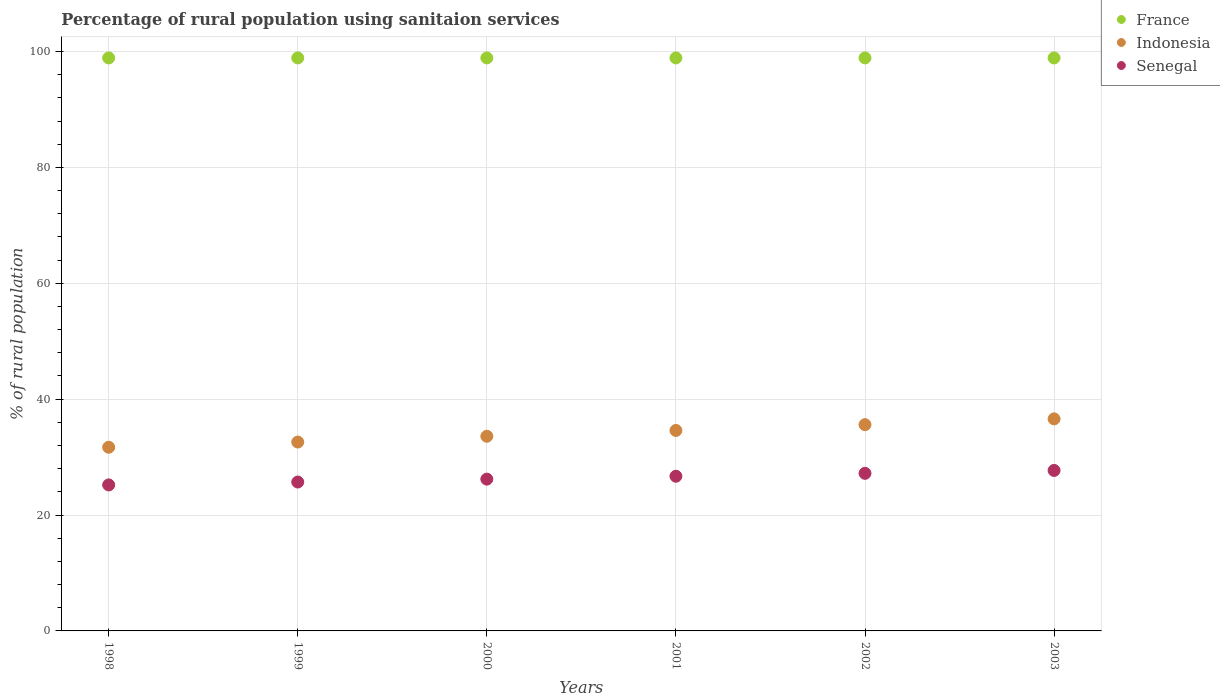How many different coloured dotlines are there?
Offer a very short reply. 3. What is the percentage of rural population using sanitaion services in Indonesia in 2001?
Your answer should be very brief. 34.6. Across all years, what is the maximum percentage of rural population using sanitaion services in Senegal?
Keep it short and to the point. 27.7. Across all years, what is the minimum percentage of rural population using sanitaion services in Senegal?
Keep it short and to the point. 25.2. In which year was the percentage of rural population using sanitaion services in Senegal maximum?
Make the answer very short. 2003. What is the total percentage of rural population using sanitaion services in France in the graph?
Offer a very short reply. 593.4. What is the difference between the percentage of rural population using sanitaion services in Senegal in 1998 and that in 2000?
Give a very brief answer. -1. What is the difference between the percentage of rural population using sanitaion services in Senegal in 2003 and the percentage of rural population using sanitaion services in Indonesia in 2001?
Your answer should be very brief. -6.9. What is the average percentage of rural population using sanitaion services in France per year?
Offer a very short reply. 98.9. In the year 1999, what is the difference between the percentage of rural population using sanitaion services in Senegal and percentage of rural population using sanitaion services in France?
Provide a succinct answer. -73.2. What is the ratio of the percentage of rural population using sanitaion services in Senegal in 2000 to that in 2001?
Your response must be concise. 0.98. What is the difference between the highest and the second highest percentage of rural population using sanitaion services in France?
Provide a short and direct response. 0. What is the difference between the highest and the lowest percentage of rural population using sanitaion services in Senegal?
Provide a succinct answer. 2.5. In how many years, is the percentage of rural population using sanitaion services in France greater than the average percentage of rural population using sanitaion services in France taken over all years?
Ensure brevity in your answer.  6. Is the sum of the percentage of rural population using sanitaion services in Senegal in 1998 and 2000 greater than the maximum percentage of rural population using sanitaion services in France across all years?
Your answer should be very brief. No. How many dotlines are there?
Provide a succinct answer. 3. How many years are there in the graph?
Offer a terse response. 6. What is the difference between two consecutive major ticks on the Y-axis?
Make the answer very short. 20. Does the graph contain any zero values?
Your answer should be compact. No. Where does the legend appear in the graph?
Your response must be concise. Top right. How many legend labels are there?
Offer a very short reply. 3. What is the title of the graph?
Your answer should be very brief. Percentage of rural population using sanitaion services. Does "OECD members" appear as one of the legend labels in the graph?
Provide a short and direct response. No. What is the label or title of the X-axis?
Your answer should be compact. Years. What is the label or title of the Y-axis?
Offer a very short reply. % of rural population. What is the % of rural population in France in 1998?
Make the answer very short. 98.9. What is the % of rural population in Indonesia in 1998?
Provide a succinct answer. 31.7. What is the % of rural population in Senegal in 1998?
Your answer should be compact. 25.2. What is the % of rural population in France in 1999?
Provide a short and direct response. 98.9. What is the % of rural population in Indonesia in 1999?
Keep it short and to the point. 32.6. What is the % of rural population in Senegal in 1999?
Your response must be concise. 25.7. What is the % of rural population of France in 2000?
Ensure brevity in your answer.  98.9. What is the % of rural population in Indonesia in 2000?
Give a very brief answer. 33.6. What is the % of rural population in Senegal in 2000?
Your answer should be very brief. 26.2. What is the % of rural population in France in 2001?
Your answer should be compact. 98.9. What is the % of rural population in Indonesia in 2001?
Provide a short and direct response. 34.6. What is the % of rural population of Senegal in 2001?
Provide a short and direct response. 26.7. What is the % of rural population of France in 2002?
Provide a short and direct response. 98.9. What is the % of rural population in Indonesia in 2002?
Your answer should be compact. 35.6. What is the % of rural population of Senegal in 2002?
Ensure brevity in your answer.  27.2. What is the % of rural population of France in 2003?
Offer a terse response. 98.9. What is the % of rural population in Indonesia in 2003?
Offer a very short reply. 36.6. What is the % of rural population in Senegal in 2003?
Make the answer very short. 27.7. Across all years, what is the maximum % of rural population of France?
Provide a short and direct response. 98.9. Across all years, what is the maximum % of rural population of Indonesia?
Provide a short and direct response. 36.6. Across all years, what is the maximum % of rural population of Senegal?
Your response must be concise. 27.7. Across all years, what is the minimum % of rural population of France?
Provide a succinct answer. 98.9. Across all years, what is the minimum % of rural population in Indonesia?
Keep it short and to the point. 31.7. Across all years, what is the minimum % of rural population of Senegal?
Make the answer very short. 25.2. What is the total % of rural population in France in the graph?
Make the answer very short. 593.4. What is the total % of rural population of Indonesia in the graph?
Ensure brevity in your answer.  204.7. What is the total % of rural population in Senegal in the graph?
Offer a terse response. 158.7. What is the difference between the % of rural population in Indonesia in 1998 and that in 1999?
Your answer should be compact. -0.9. What is the difference between the % of rural population in Indonesia in 1998 and that in 2000?
Keep it short and to the point. -1.9. What is the difference between the % of rural population in France in 1998 and that in 2001?
Provide a short and direct response. 0. What is the difference between the % of rural population in Senegal in 1998 and that in 2002?
Make the answer very short. -2. What is the difference between the % of rural population in Senegal in 1998 and that in 2003?
Make the answer very short. -2.5. What is the difference between the % of rural population of France in 1999 and that in 2000?
Make the answer very short. 0. What is the difference between the % of rural population in Indonesia in 1999 and that in 2000?
Your response must be concise. -1. What is the difference between the % of rural population in Senegal in 1999 and that in 2000?
Give a very brief answer. -0.5. What is the difference between the % of rural population of Indonesia in 1999 and that in 2001?
Provide a short and direct response. -2. What is the difference between the % of rural population in Senegal in 1999 and that in 2001?
Provide a short and direct response. -1. What is the difference between the % of rural population of France in 1999 and that in 2002?
Your answer should be compact. 0. What is the difference between the % of rural population in France in 2000 and that in 2001?
Provide a succinct answer. 0. What is the difference between the % of rural population in Indonesia in 2000 and that in 2001?
Your answer should be compact. -1. What is the difference between the % of rural population in Senegal in 2000 and that in 2001?
Make the answer very short. -0.5. What is the difference between the % of rural population of Indonesia in 2000 and that in 2002?
Make the answer very short. -2. What is the difference between the % of rural population of Senegal in 2000 and that in 2002?
Your answer should be compact. -1. What is the difference between the % of rural population in France in 2001 and that in 2002?
Your answer should be compact. 0. What is the difference between the % of rural population of Indonesia in 2001 and that in 2002?
Give a very brief answer. -1. What is the difference between the % of rural population of France in 2001 and that in 2003?
Give a very brief answer. 0. What is the difference between the % of rural population of Indonesia in 2001 and that in 2003?
Provide a short and direct response. -2. What is the difference between the % of rural population in Senegal in 2001 and that in 2003?
Provide a short and direct response. -1. What is the difference between the % of rural population of Senegal in 2002 and that in 2003?
Ensure brevity in your answer.  -0.5. What is the difference between the % of rural population in France in 1998 and the % of rural population in Indonesia in 1999?
Provide a short and direct response. 66.3. What is the difference between the % of rural population in France in 1998 and the % of rural population in Senegal in 1999?
Offer a terse response. 73.2. What is the difference between the % of rural population in Indonesia in 1998 and the % of rural population in Senegal in 1999?
Offer a terse response. 6. What is the difference between the % of rural population in France in 1998 and the % of rural population in Indonesia in 2000?
Give a very brief answer. 65.3. What is the difference between the % of rural population of France in 1998 and the % of rural population of Senegal in 2000?
Your response must be concise. 72.7. What is the difference between the % of rural population of France in 1998 and the % of rural population of Indonesia in 2001?
Your answer should be compact. 64.3. What is the difference between the % of rural population in France in 1998 and the % of rural population in Senegal in 2001?
Ensure brevity in your answer.  72.2. What is the difference between the % of rural population of Indonesia in 1998 and the % of rural population of Senegal in 2001?
Your answer should be very brief. 5. What is the difference between the % of rural population of France in 1998 and the % of rural population of Indonesia in 2002?
Provide a succinct answer. 63.3. What is the difference between the % of rural population of France in 1998 and the % of rural population of Senegal in 2002?
Give a very brief answer. 71.7. What is the difference between the % of rural population of France in 1998 and the % of rural population of Indonesia in 2003?
Your response must be concise. 62.3. What is the difference between the % of rural population of France in 1998 and the % of rural population of Senegal in 2003?
Your answer should be very brief. 71.2. What is the difference between the % of rural population of France in 1999 and the % of rural population of Indonesia in 2000?
Your answer should be compact. 65.3. What is the difference between the % of rural population in France in 1999 and the % of rural population in Senegal in 2000?
Provide a succinct answer. 72.7. What is the difference between the % of rural population of Indonesia in 1999 and the % of rural population of Senegal in 2000?
Provide a succinct answer. 6.4. What is the difference between the % of rural population of France in 1999 and the % of rural population of Indonesia in 2001?
Give a very brief answer. 64.3. What is the difference between the % of rural population in France in 1999 and the % of rural population in Senegal in 2001?
Provide a short and direct response. 72.2. What is the difference between the % of rural population in France in 1999 and the % of rural population in Indonesia in 2002?
Make the answer very short. 63.3. What is the difference between the % of rural population in France in 1999 and the % of rural population in Senegal in 2002?
Your answer should be compact. 71.7. What is the difference between the % of rural population of France in 1999 and the % of rural population of Indonesia in 2003?
Provide a succinct answer. 62.3. What is the difference between the % of rural population in France in 1999 and the % of rural population in Senegal in 2003?
Make the answer very short. 71.2. What is the difference between the % of rural population in Indonesia in 1999 and the % of rural population in Senegal in 2003?
Provide a short and direct response. 4.9. What is the difference between the % of rural population of France in 2000 and the % of rural population of Indonesia in 2001?
Provide a succinct answer. 64.3. What is the difference between the % of rural population in France in 2000 and the % of rural population in Senegal in 2001?
Keep it short and to the point. 72.2. What is the difference between the % of rural population in Indonesia in 2000 and the % of rural population in Senegal in 2001?
Provide a succinct answer. 6.9. What is the difference between the % of rural population of France in 2000 and the % of rural population of Indonesia in 2002?
Offer a very short reply. 63.3. What is the difference between the % of rural population of France in 2000 and the % of rural population of Senegal in 2002?
Your response must be concise. 71.7. What is the difference between the % of rural population of Indonesia in 2000 and the % of rural population of Senegal in 2002?
Your response must be concise. 6.4. What is the difference between the % of rural population of France in 2000 and the % of rural population of Indonesia in 2003?
Provide a short and direct response. 62.3. What is the difference between the % of rural population in France in 2000 and the % of rural population in Senegal in 2003?
Keep it short and to the point. 71.2. What is the difference between the % of rural population in Indonesia in 2000 and the % of rural population in Senegal in 2003?
Keep it short and to the point. 5.9. What is the difference between the % of rural population in France in 2001 and the % of rural population in Indonesia in 2002?
Make the answer very short. 63.3. What is the difference between the % of rural population in France in 2001 and the % of rural population in Senegal in 2002?
Offer a terse response. 71.7. What is the difference between the % of rural population of France in 2001 and the % of rural population of Indonesia in 2003?
Provide a short and direct response. 62.3. What is the difference between the % of rural population in France in 2001 and the % of rural population in Senegal in 2003?
Your response must be concise. 71.2. What is the difference between the % of rural population of France in 2002 and the % of rural population of Indonesia in 2003?
Your response must be concise. 62.3. What is the difference between the % of rural population in France in 2002 and the % of rural population in Senegal in 2003?
Make the answer very short. 71.2. What is the average % of rural population in France per year?
Give a very brief answer. 98.9. What is the average % of rural population in Indonesia per year?
Your answer should be very brief. 34.12. What is the average % of rural population in Senegal per year?
Give a very brief answer. 26.45. In the year 1998, what is the difference between the % of rural population of France and % of rural population of Indonesia?
Offer a very short reply. 67.2. In the year 1998, what is the difference between the % of rural population in France and % of rural population in Senegal?
Make the answer very short. 73.7. In the year 1998, what is the difference between the % of rural population of Indonesia and % of rural population of Senegal?
Your answer should be very brief. 6.5. In the year 1999, what is the difference between the % of rural population of France and % of rural population of Indonesia?
Ensure brevity in your answer.  66.3. In the year 1999, what is the difference between the % of rural population of France and % of rural population of Senegal?
Offer a terse response. 73.2. In the year 2000, what is the difference between the % of rural population of France and % of rural population of Indonesia?
Your answer should be compact. 65.3. In the year 2000, what is the difference between the % of rural population of France and % of rural population of Senegal?
Keep it short and to the point. 72.7. In the year 2001, what is the difference between the % of rural population in France and % of rural population in Indonesia?
Ensure brevity in your answer.  64.3. In the year 2001, what is the difference between the % of rural population in France and % of rural population in Senegal?
Provide a succinct answer. 72.2. In the year 2001, what is the difference between the % of rural population of Indonesia and % of rural population of Senegal?
Ensure brevity in your answer.  7.9. In the year 2002, what is the difference between the % of rural population of France and % of rural population of Indonesia?
Your answer should be compact. 63.3. In the year 2002, what is the difference between the % of rural population of France and % of rural population of Senegal?
Offer a terse response. 71.7. In the year 2002, what is the difference between the % of rural population in Indonesia and % of rural population in Senegal?
Your response must be concise. 8.4. In the year 2003, what is the difference between the % of rural population of France and % of rural population of Indonesia?
Give a very brief answer. 62.3. In the year 2003, what is the difference between the % of rural population in France and % of rural population in Senegal?
Your response must be concise. 71.2. What is the ratio of the % of rural population of France in 1998 to that in 1999?
Give a very brief answer. 1. What is the ratio of the % of rural population in Indonesia in 1998 to that in 1999?
Offer a very short reply. 0.97. What is the ratio of the % of rural population in Senegal in 1998 to that in 1999?
Your response must be concise. 0.98. What is the ratio of the % of rural population of France in 1998 to that in 2000?
Your answer should be compact. 1. What is the ratio of the % of rural population in Indonesia in 1998 to that in 2000?
Provide a short and direct response. 0.94. What is the ratio of the % of rural population in Senegal in 1998 to that in 2000?
Keep it short and to the point. 0.96. What is the ratio of the % of rural population in Indonesia in 1998 to that in 2001?
Your answer should be compact. 0.92. What is the ratio of the % of rural population of Senegal in 1998 to that in 2001?
Offer a terse response. 0.94. What is the ratio of the % of rural population of Indonesia in 1998 to that in 2002?
Your answer should be compact. 0.89. What is the ratio of the % of rural population of Senegal in 1998 to that in 2002?
Provide a succinct answer. 0.93. What is the ratio of the % of rural population in Indonesia in 1998 to that in 2003?
Your answer should be compact. 0.87. What is the ratio of the % of rural population of Senegal in 1998 to that in 2003?
Your answer should be compact. 0.91. What is the ratio of the % of rural population of Indonesia in 1999 to that in 2000?
Offer a very short reply. 0.97. What is the ratio of the % of rural population of Senegal in 1999 to that in 2000?
Give a very brief answer. 0.98. What is the ratio of the % of rural population in Indonesia in 1999 to that in 2001?
Your response must be concise. 0.94. What is the ratio of the % of rural population of Senegal in 1999 to that in 2001?
Provide a short and direct response. 0.96. What is the ratio of the % of rural population of France in 1999 to that in 2002?
Your answer should be compact. 1. What is the ratio of the % of rural population of Indonesia in 1999 to that in 2002?
Your answer should be very brief. 0.92. What is the ratio of the % of rural population of Senegal in 1999 to that in 2002?
Your response must be concise. 0.94. What is the ratio of the % of rural population of Indonesia in 1999 to that in 2003?
Your response must be concise. 0.89. What is the ratio of the % of rural population in Senegal in 1999 to that in 2003?
Make the answer very short. 0.93. What is the ratio of the % of rural population in Indonesia in 2000 to that in 2001?
Your response must be concise. 0.97. What is the ratio of the % of rural population of Senegal in 2000 to that in 2001?
Provide a short and direct response. 0.98. What is the ratio of the % of rural population of France in 2000 to that in 2002?
Your response must be concise. 1. What is the ratio of the % of rural population of Indonesia in 2000 to that in 2002?
Provide a succinct answer. 0.94. What is the ratio of the % of rural population of Senegal in 2000 to that in 2002?
Provide a short and direct response. 0.96. What is the ratio of the % of rural population in Indonesia in 2000 to that in 2003?
Make the answer very short. 0.92. What is the ratio of the % of rural population in Senegal in 2000 to that in 2003?
Give a very brief answer. 0.95. What is the ratio of the % of rural population in Indonesia in 2001 to that in 2002?
Ensure brevity in your answer.  0.97. What is the ratio of the % of rural population of Senegal in 2001 to that in 2002?
Your response must be concise. 0.98. What is the ratio of the % of rural population of Indonesia in 2001 to that in 2003?
Ensure brevity in your answer.  0.95. What is the ratio of the % of rural population in Senegal in 2001 to that in 2003?
Your answer should be very brief. 0.96. What is the ratio of the % of rural population of Indonesia in 2002 to that in 2003?
Make the answer very short. 0.97. What is the ratio of the % of rural population in Senegal in 2002 to that in 2003?
Your answer should be very brief. 0.98. What is the difference between the highest and the lowest % of rural population in France?
Give a very brief answer. 0. What is the difference between the highest and the lowest % of rural population in Indonesia?
Your answer should be compact. 4.9. What is the difference between the highest and the lowest % of rural population of Senegal?
Offer a very short reply. 2.5. 